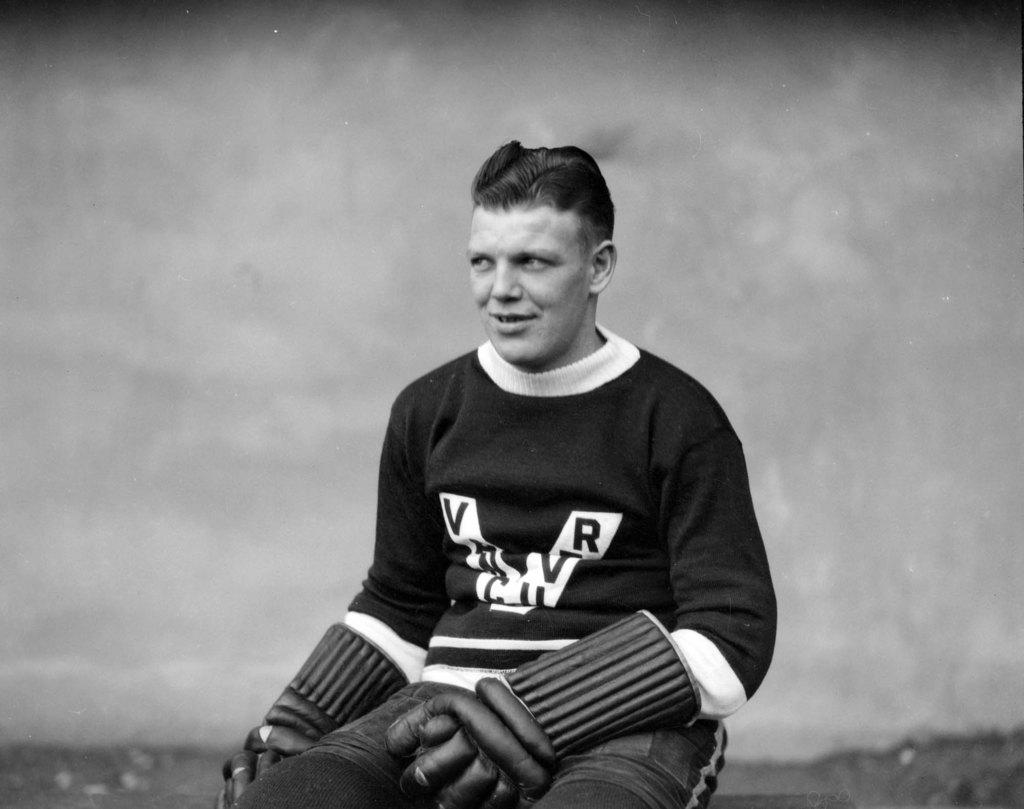Provide a one-sentence caption for the provided image. An athlete wearing a jersey with the letters V and R on it. 